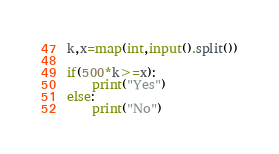Convert code to text. <code><loc_0><loc_0><loc_500><loc_500><_Python_>k,x=map(int,input().split())

if(500*k>=x):
    print("Yes")
else:
    print("No")</code> 